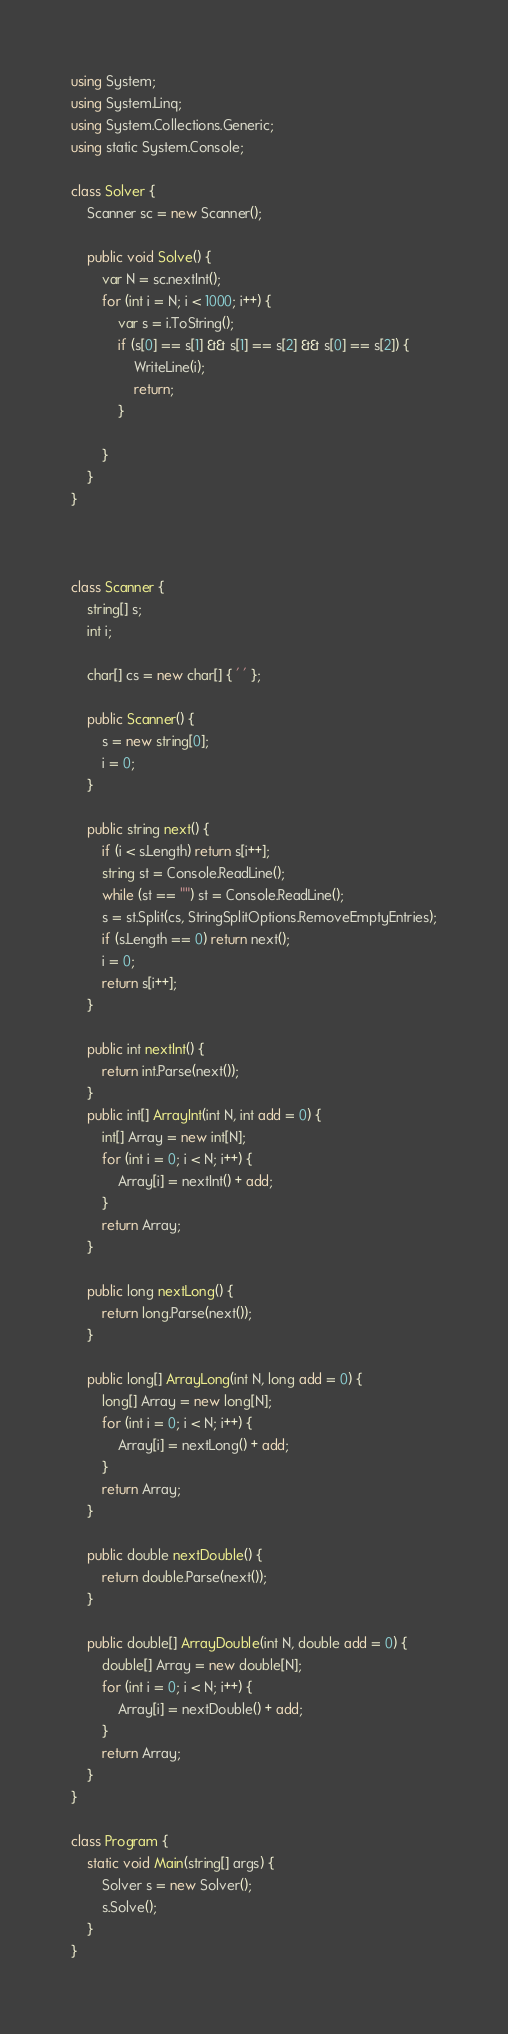<code> <loc_0><loc_0><loc_500><loc_500><_C#_>using System;
using System.Linq;
using System.Collections.Generic;
using static System.Console;

class Solver {
    Scanner sc = new Scanner();

    public void Solve() {
        var N = sc.nextInt();
        for (int i = N; i < 1000; i++) {
            var s = i.ToString();
            if (s[0] == s[1] && s[1] == s[2] && s[0] == s[2]) {
                WriteLine(i);
                return;
            }

        }
    }
}



class Scanner {
    string[] s;
    int i;

    char[] cs = new char[] { ' ' };

    public Scanner() {
        s = new string[0];
        i = 0;
    }

    public string next() {
        if (i < s.Length) return s[i++];
        string st = Console.ReadLine();
        while (st == "") st = Console.ReadLine();
        s = st.Split(cs, StringSplitOptions.RemoveEmptyEntries);
        if (s.Length == 0) return next();
        i = 0;
        return s[i++];
    }

    public int nextInt() {
        return int.Parse(next());
    }
    public int[] ArrayInt(int N, int add = 0) {
        int[] Array = new int[N];
        for (int i = 0; i < N; i++) {
            Array[i] = nextInt() + add;
        }
        return Array;
    }

    public long nextLong() {
        return long.Parse(next());
    }

    public long[] ArrayLong(int N, long add = 0) {
        long[] Array = new long[N];
        for (int i = 0; i < N; i++) {
            Array[i] = nextLong() + add;
        }
        return Array;
    }

    public double nextDouble() {
        return double.Parse(next());
    }

    public double[] ArrayDouble(int N, double add = 0) {
        double[] Array = new double[N];
        for (int i = 0; i < N; i++) {
            Array[i] = nextDouble() + add;
        }
        return Array;
    }
}

class Program {
    static void Main(string[] args) {
        Solver s = new Solver();
        s.Solve();
    }
}
</code> 